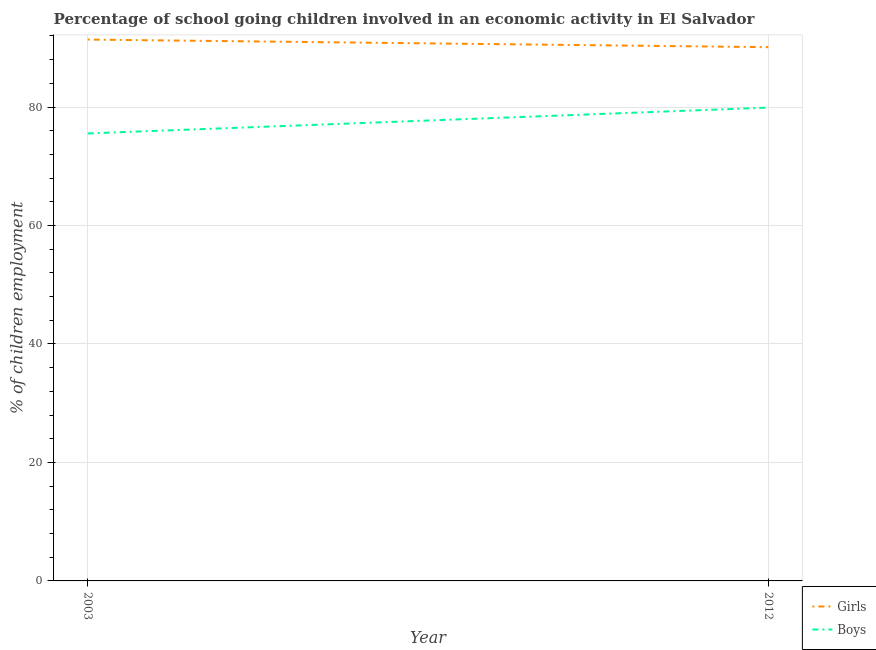What is the percentage of school going boys in 2003?
Keep it short and to the point. 75.53. Across all years, what is the maximum percentage of school going girls?
Provide a succinct answer. 91.38. Across all years, what is the minimum percentage of school going girls?
Ensure brevity in your answer.  90.1. In which year was the percentage of school going boys minimum?
Give a very brief answer. 2003. What is the total percentage of school going girls in the graph?
Provide a short and direct response. 181.48. What is the difference between the percentage of school going boys in 2003 and that in 2012?
Ensure brevity in your answer.  -4.37. What is the difference between the percentage of school going girls in 2012 and the percentage of school going boys in 2003?
Make the answer very short. 14.57. What is the average percentage of school going boys per year?
Offer a very short reply. 77.72. In the year 2003, what is the difference between the percentage of school going girls and percentage of school going boys?
Give a very brief answer. 15.85. What is the ratio of the percentage of school going boys in 2003 to that in 2012?
Your answer should be very brief. 0.95. In how many years, is the percentage of school going boys greater than the average percentage of school going boys taken over all years?
Give a very brief answer. 1. How many lines are there?
Ensure brevity in your answer.  2. How many years are there in the graph?
Give a very brief answer. 2. Are the values on the major ticks of Y-axis written in scientific E-notation?
Offer a very short reply. No. Does the graph contain grids?
Provide a succinct answer. Yes. Where does the legend appear in the graph?
Your answer should be very brief. Bottom right. How many legend labels are there?
Give a very brief answer. 2. How are the legend labels stacked?
Provide a short and direct response. Vertical. What is the title of the graph?
Keep it short and to the point. Percentage of school going children involved in an economic activity in El Salvador. What is the label or title of the Y-axis?
Keep it short and to the point. % of children employment. What is the % of children employment of Girls in 2003?
Keep it short and to the point. 91.38. What is the % of children employment of Boys in 2003?
Make the answer very short. 75.53. What is the % of children employment of Girls in 2012?
Make the answer very short. 90.1. What is the % of children employment in Boys in 2012?
Your answer should be compact. 79.9. Across all years, what is the maximum % of children employment of Girls?
Offer a terse response. 91.38. Across all years, what is the maximum % of children employment of Boys?
Your answer should be very brief. 79.9. Across all years, what is the minimum % of children employment in Girls?
Make the answer very short. 90.1. Across all years, what is the minimum % of children employment in Boys?
Give a very brief answer. 75.53. What is the total % of children employment of Girls in the graph?
Provide a succinct answer. 181.48. What is the total % of children employment in Boys in the graph?
Offer a terse response. 155.43. What is the difference between the % of children employment of Girls in 2003 and that in 2012?
Provide a short and direct response. 1.28. What is the difference between the % of children employment of Boys in 2003 and that in 2012?
Keep it short and to the point. -4.37. What is the difference between the % of children employment in Girls in 2003 and the % of children employment in Boys in 2012?
Make the answer very short. 11.48. What is the average % of children employment of Girls per year?
Offer a terse response. 90.74. What is the average % of children employment of Boys per year?
Your response must be concise. 77.72. In the year 2003, what is the difference between the % of children employment in Girls and % of children employment in Boys?
Offer a terse response. 15.85. What is the ratio of the % of children employment of Girls in 2003 to that in 2012?
Offer a terse response. 1.01. What is the ratio of the % of children employment of Boys in 2003 to that in 2012?
Offer a very short reply. 0.95. What is the difference between the highest and the second highest % of children employment in Girls?
Give a very brief answer. 1.28. What is the difference between the highest and the second highest % of children employment in Boys?
Give a very brief answer. 4.37. What is the difference between the highest and the lowest % of children employment in Girls?
Provide a succinct answer. 1.28. What is the difference between the highest and the lowest % of children employment in Boys?
Your answer should be very brief. 4.37. 